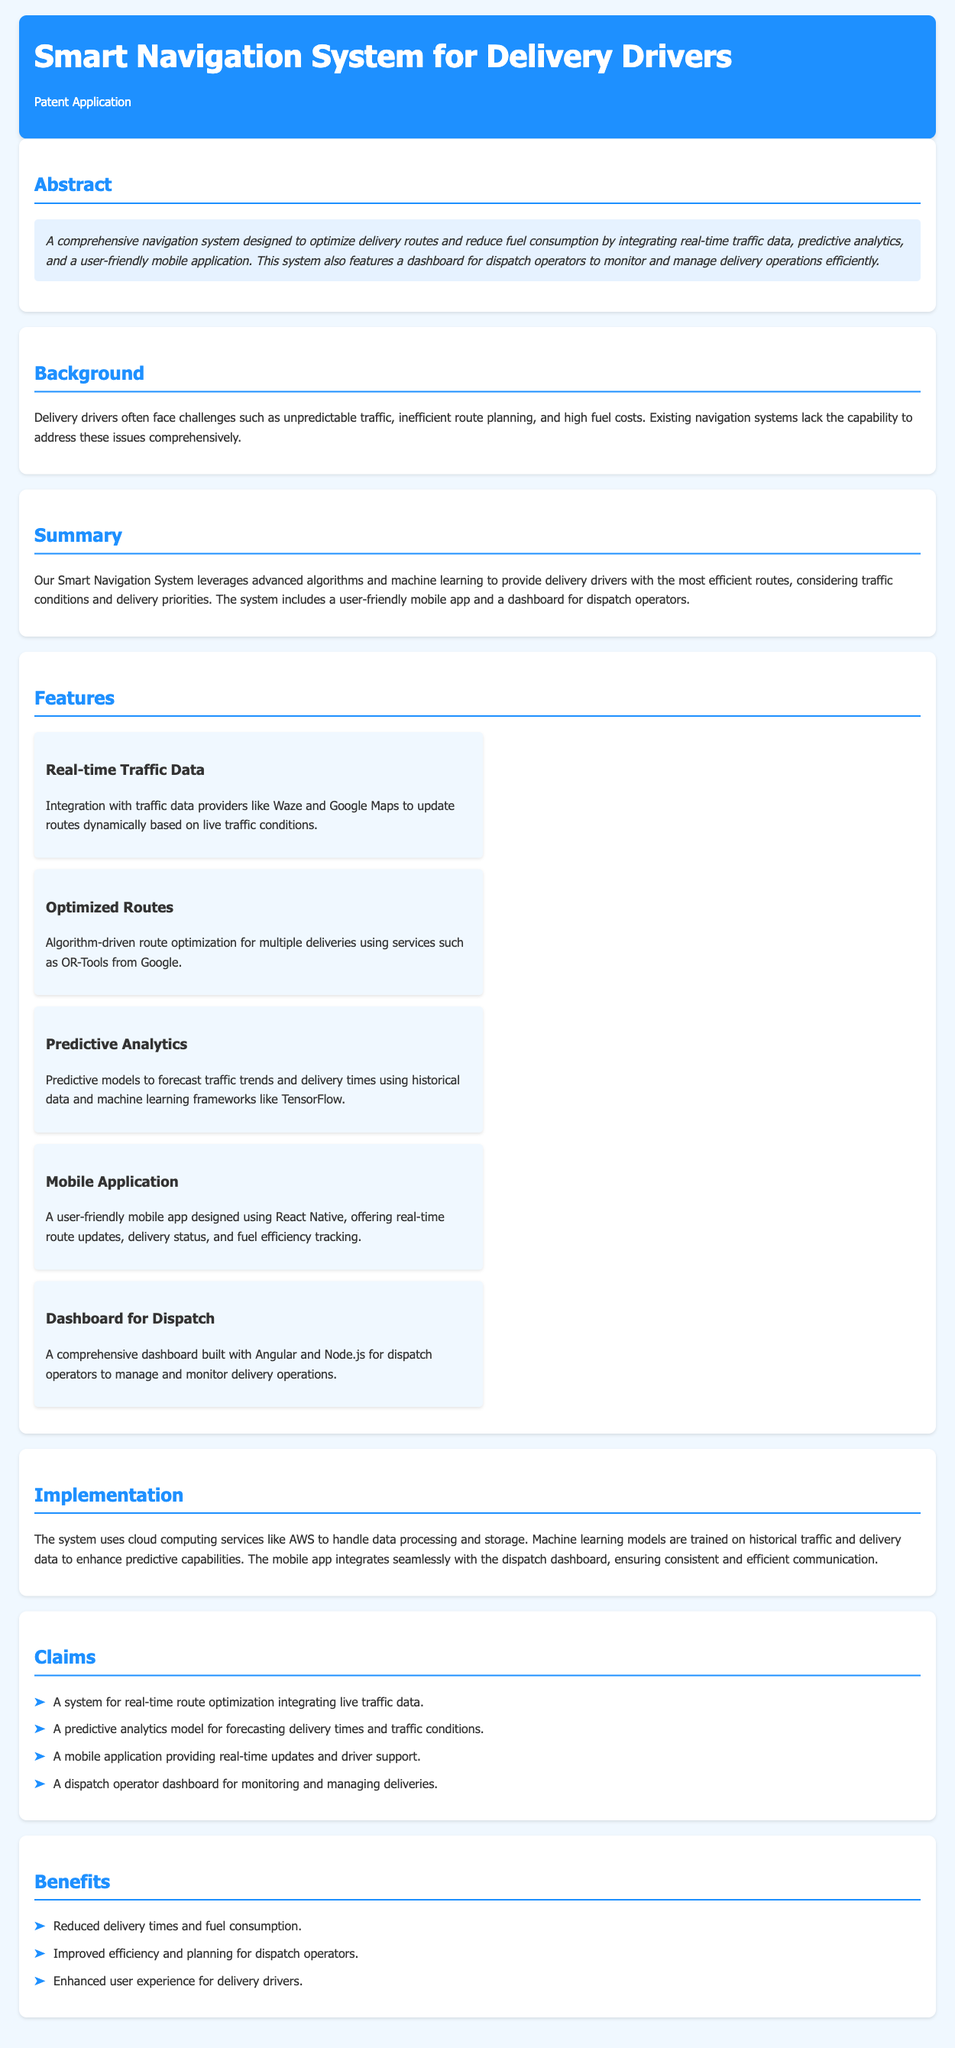What is the title of the patent application? The title of the patent application is specified in the header of the document.
Answer: Smart Navigation System for Delivery Drivers Who are the traffic data providers mentioned? The document lists two specific traffic data providers as part of the features section.
Answer: Waze and Google Maps What technology is used for the mobile application development? The technology used for developing the mobile application is mentioned as part of the features.
Answer: React Native What is the purpose of the predictive analytics model? The document explains the use of predictive analytics in the claims section, detailing its purpose.
Answer: Forecasting delivery times and traffic conditions How does the system reduce delivery times? The document outlines how the system enhances efficiency and planning, which inherently leads to reduced times.
Answer: Real-time route optimization What is a key benefit of the dispatch operator dashboard? The benefits section highlights specific advantages of the dashboard for dispatch operators.
Answer: Improved efficiency and planning for dispatch operators 